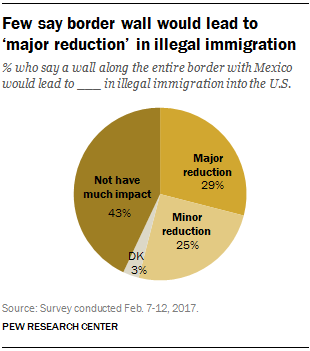Give some essential details in this illustration. The largest segment value is not two times the value of the Major reduction segment. The color of the DK segment is gray. 